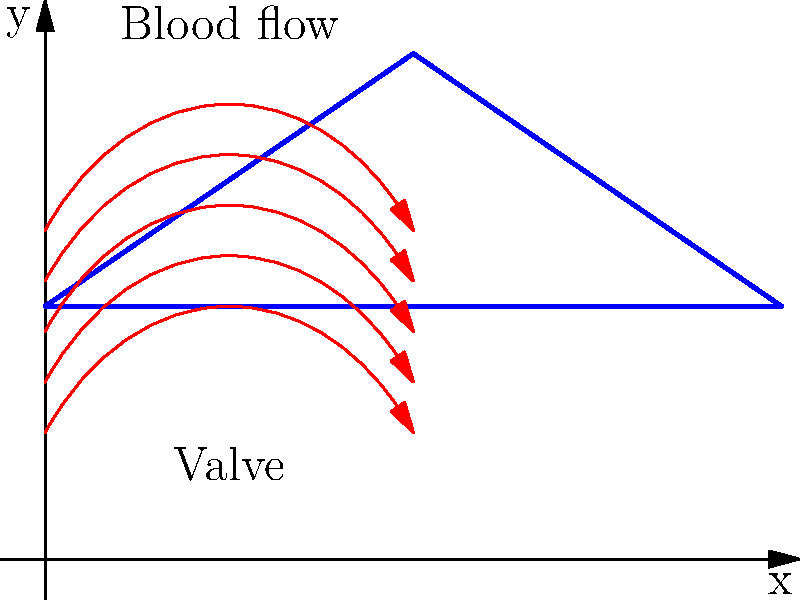In an artificial heart valve, blood flow can be modeled using fluid dynamics principles. If the velocity of blood flow through the valve is represented by the equation $v(x) = v_0 \sin(\frac{\pi x}{L})$, where $v_0$ is the maximum velocity, $x$ is the position along the valve, and $L$ is the length of the valve, what is the average velocity of blood flow through the valve? To find the average velocity of blood flow through the valve, we need to follow these steps:

1. Understand the given velocity equation:
   $v(x) = v_0 \sin(\frac{\pi x}{L})$

2. The average velocity is calculated by integrating the velocity function over the length of the valve and dividing by the length:
   $v_{avg} = \frac{1}{L} \int_0^L v(x) dx$

3. Substitute the velocity function into the integral:
   $v_{avg} = \frac{1}{L} \int_0^L v_0 \sin(\frac{\pi x}{L}) dx$

4. Factor out the constant $v_0$:
   $v_{avg} = \frac{v_0}{L} \int_0^L \sin(\frac{\pi x}{L}) dx$

5. Solve the integral:
   $v_{avg} = \frac{v_0}{L} [-\frac{L}{\pi} \cos(\frac{\pi x}{L})]_0^L$

6. Evaluate the integral at the limits:
   $v_{avg} = \frac{v_0}{L} [-\frac{L}{\pi} \cos(\pi) - (-\frac{L}{\pi} \cos(0))]$

7. Simplify:
   $v_{avg} = \frac{v_0}{L} [-\frac{L}{\pi} (-1) - (-\frac{L}{\pi} (1))]$
   $v_{avg} = \frac{v_0}{L} [\frac{L}{\pi} + \frac{L}{\pi}]$
   $v_{avg} = \frac{v_0}{L} [\frac{2L}{\pi}]$

8. Cancel out $L$:
   $v_{avg} = v_0 [\frac{2}{\pi}]$

Therefore, the average velocity of blood flow through the valve is $\frac{2}{\pi}v_0$.
Answer: $\frac{2}{\pi}v_0$ 